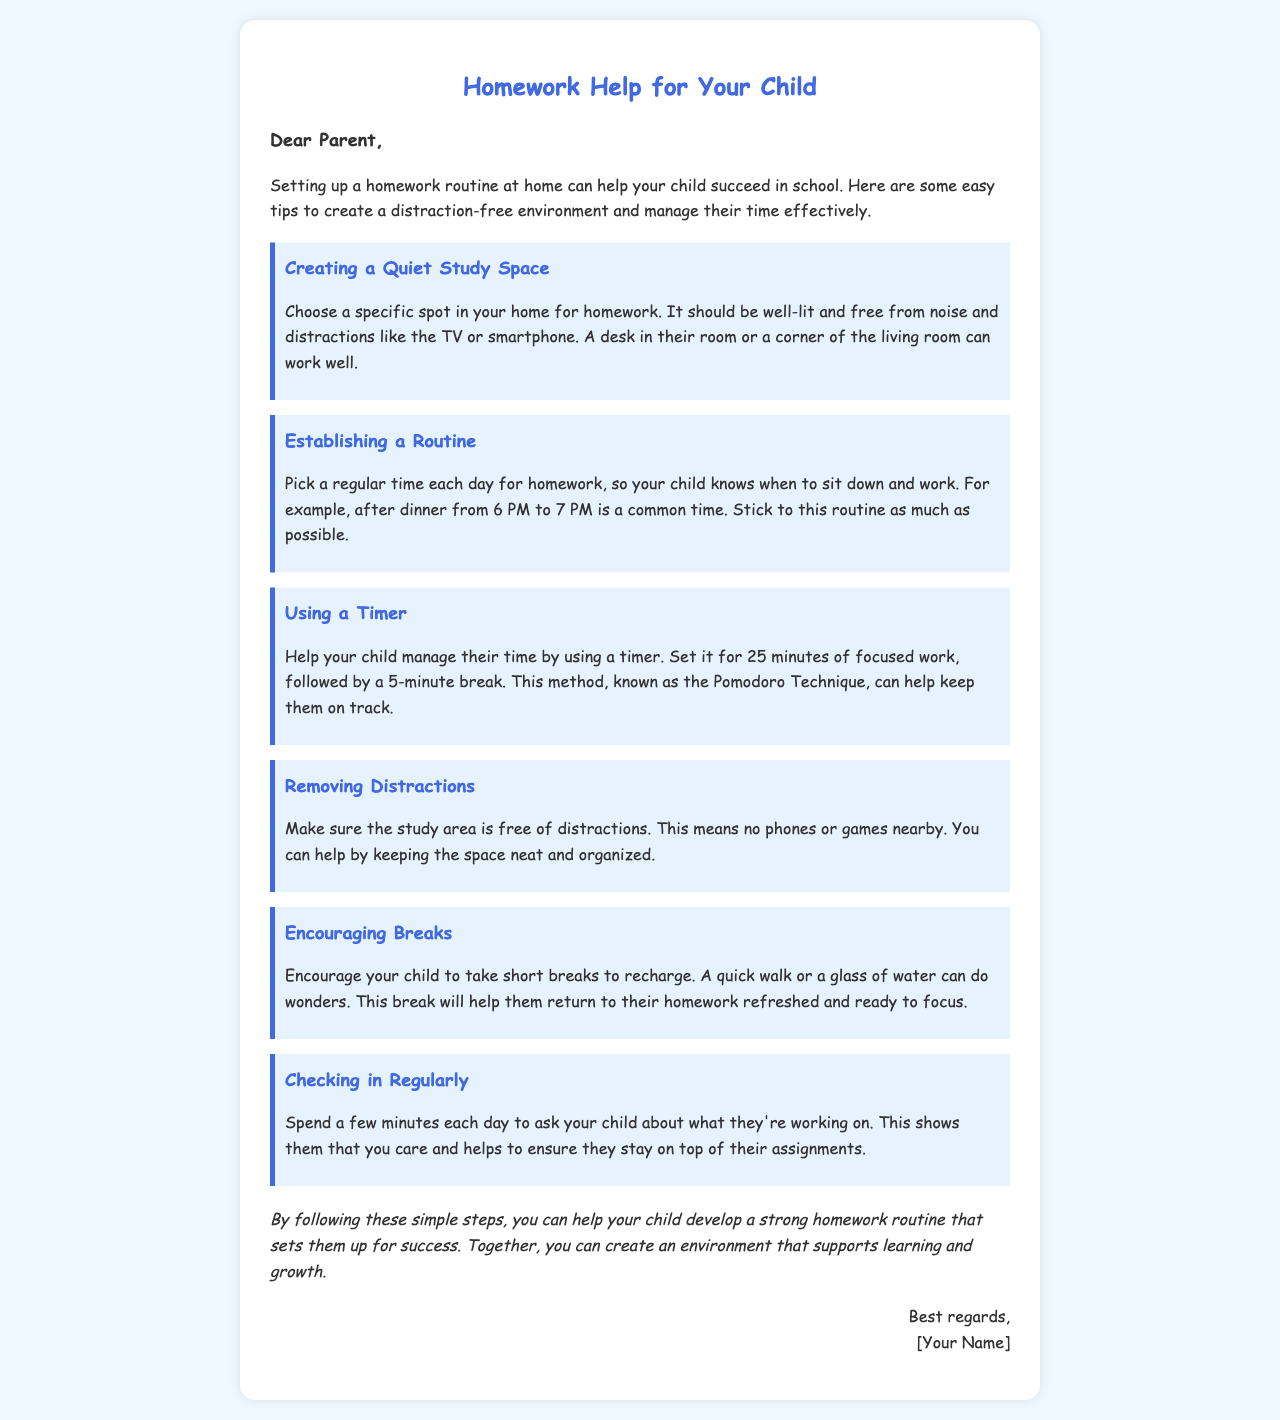What is the title of the document? The title is the main heading presented at the top of the letter, which indicates the document's purpose.
Answer: Homework Help for Your Child What should be selected for the study space? The document specifies what characteristics a good study space should have for effective learning.
Answer: Specific spot What time is suggested for homework? The letter provides an example time for when homework should be done to establish a routine.
Answer: After dinner from 6 PM to 7 PM What technique is mentioned for time management? The document refers to a particular method to help manage homework time effectively.
Answer: Pomodoro Technique How long should focused work last before a break? The document specifies the duration for work sessions before taking short breaks.
Answer: 25 minutes What activity is suggested during breaks? The letter advises on a simple activity that can refresh your child during short breaks.
Answer: Quick walk What is one way to remove distractions? The document provides advice on how to keep the study area organized and distraction-free.
Answer: Keep the space neat What is mentioned to check in with your child about? The letter suggests what you should ask your child during daily check-ins to show support.
Answer: What they're working on Who is the closing addressed to? The closing section of the letter indicates to whom the sign-off is aimed.
Answer: Parent 